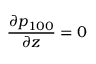<formula> <loc_0><loc_0><loc_500><loc_500>\frac { \partial p _ { 1 0 0 } } { \partial z } = 0</formula> 